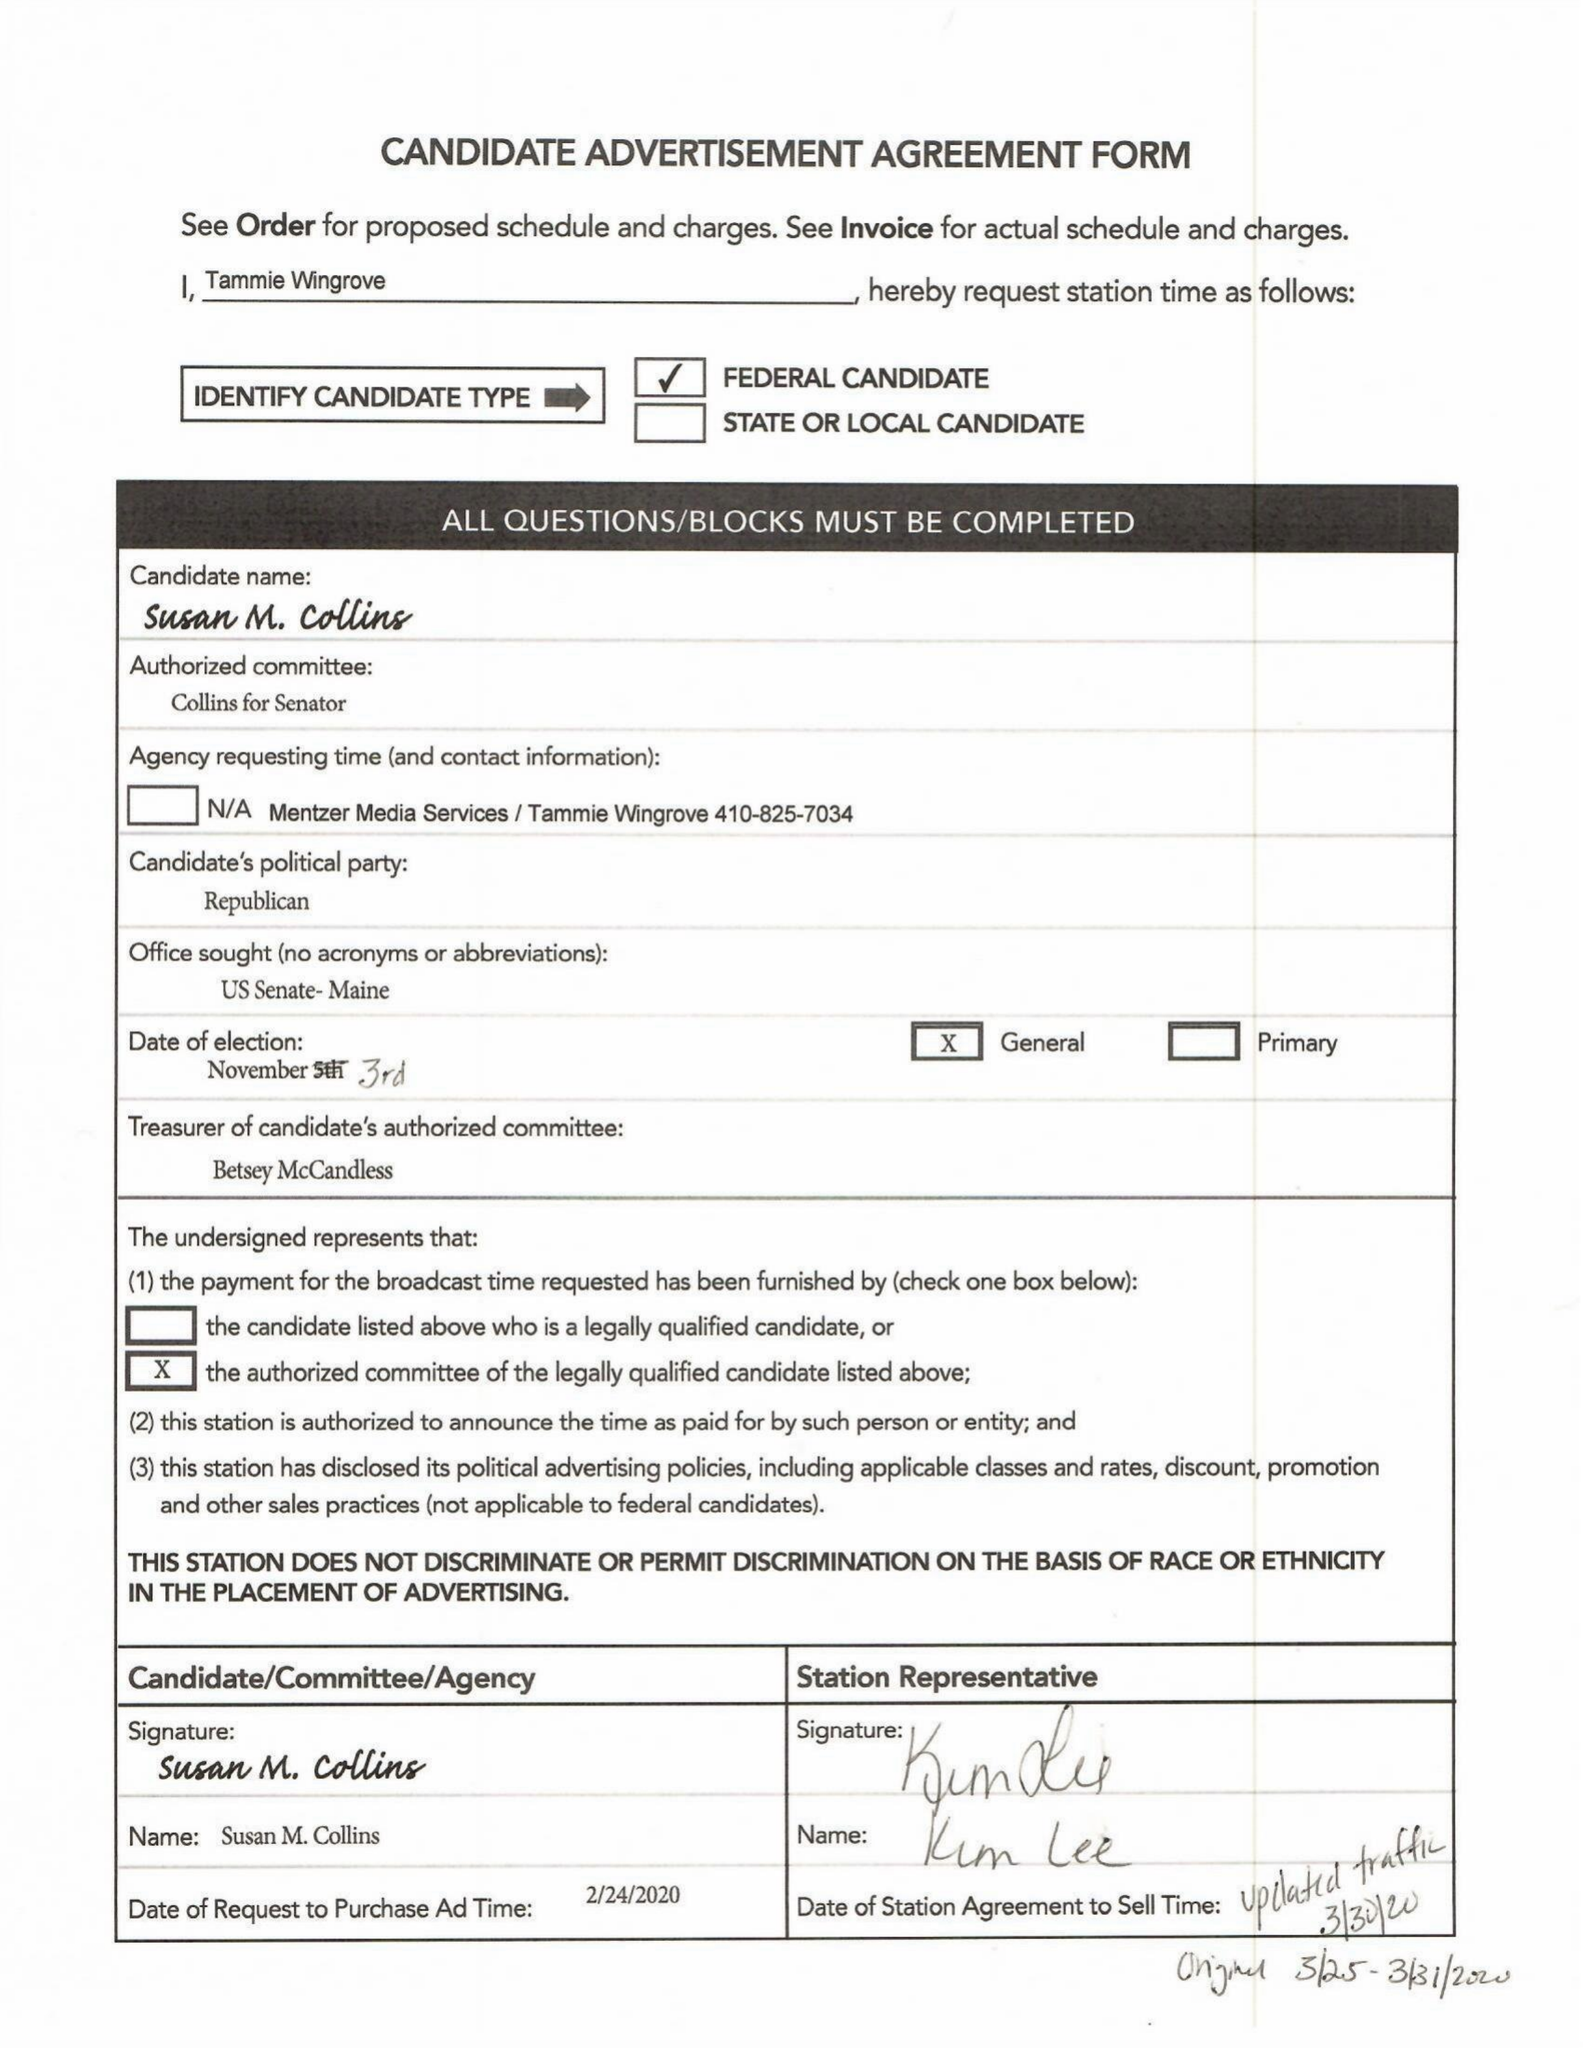What is the value for the flight_to?
Answer the question using a single word or phrase. 03/31/20 